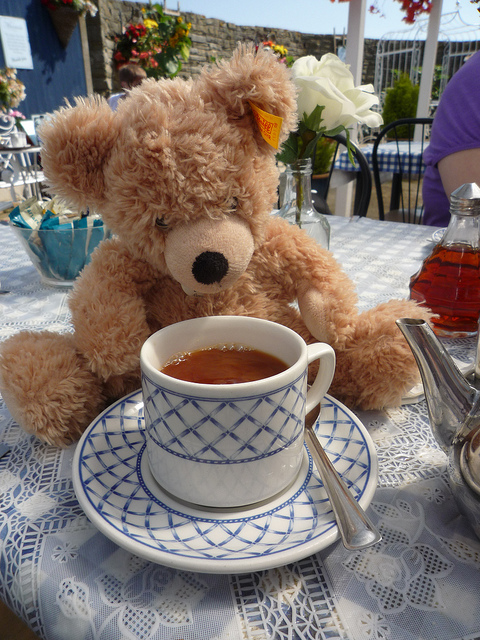Can you describe the setting in which this teddy bear is placed and what it might suggest about the owner or the environment? The teddy bear is sitting at a table with a cup of tea and a teapot visible nearby, which suggests a leisurely, comfortable setting. The presence of fresh flowers and the use of a lace tablecloth indicate that the owner appreciates a touch of refinement and enjoys creating a pleasant, inviting atmosphere for relaxation or social visits. 